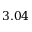<formula> <loc_0><loc_0><loc_500><loc_500>3 . 0 4</formula> 